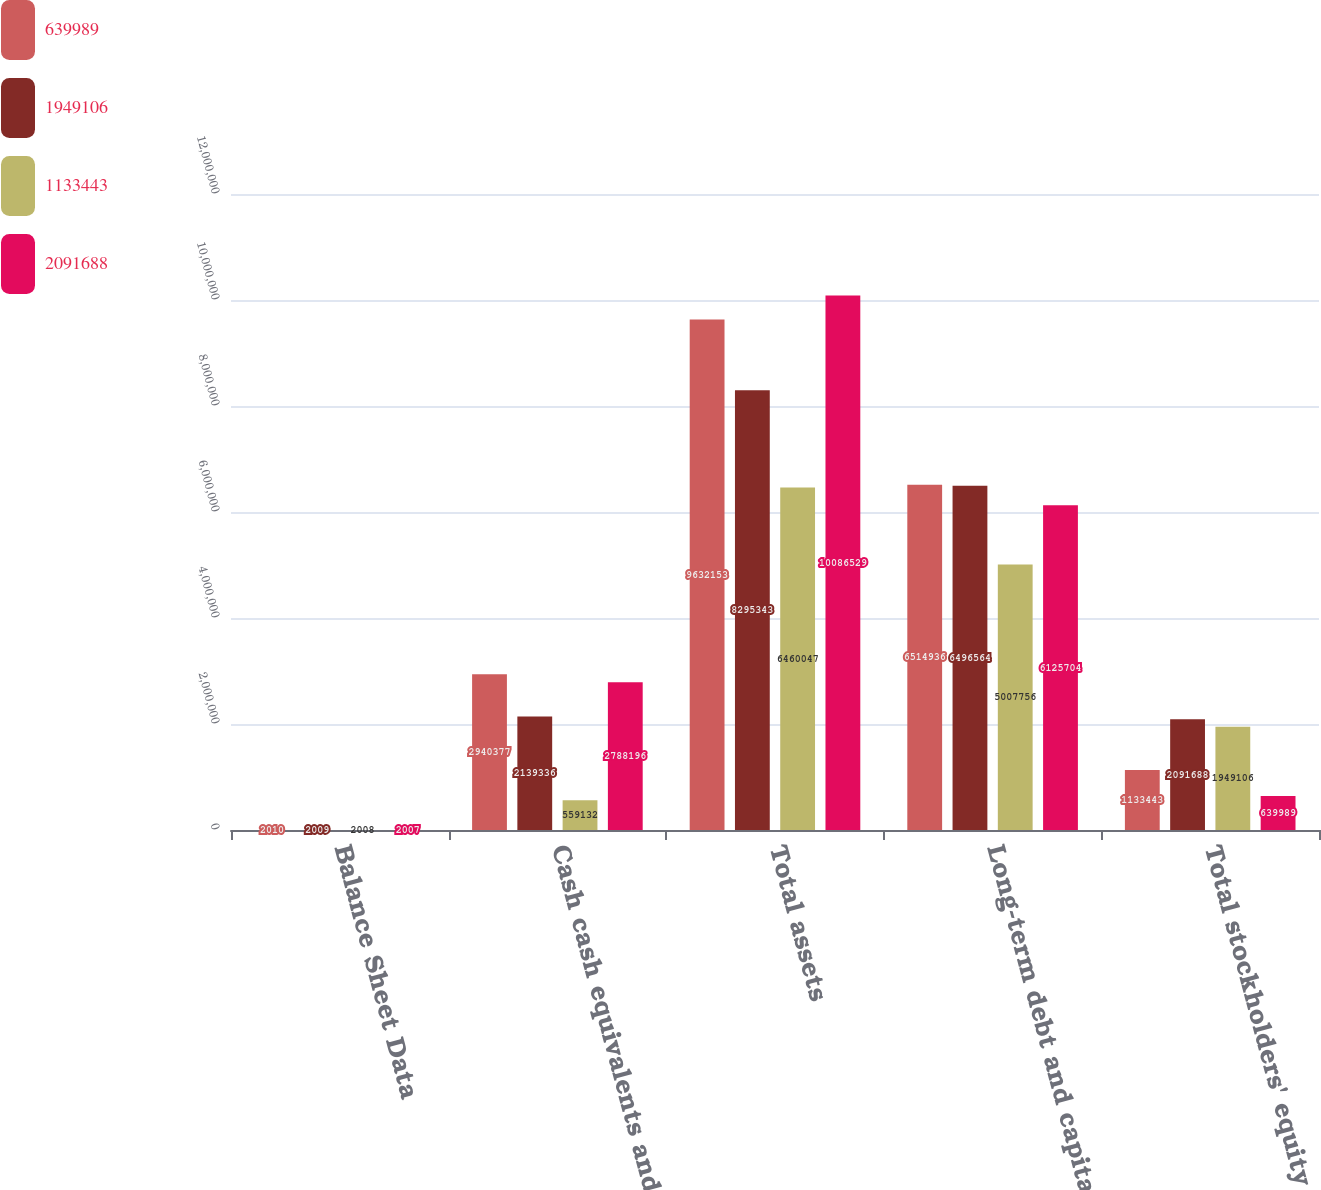Convert chart to OTSL. <chart><loc_0><loc_0><loc_500><loc_500><stacked_bar_chart><ecel><fcel>Balance Sheet Data<fcel>Cash cash equivalents and<fcel>Total assets<fcel>Long-term debt and capital<fcel>Total stockholders' equity<nl><fcel>639989<fcel>2010<fcel>2.94038e+06<fcel>9.63215e+06<fcel>6.51494e+06<fcel>1.13344e+06<nl><fcel>1.94911e+06<fcel>2009<fcel>2.13934e+06<fcel>8.29534e+06<fcel>6.49656e+06<fcel>2.09169e+06<nl><fcel>1.13344e+06<fcel>2008<fcel>559132<fcel>6.46005e+06<fcel>5.00776e+06<fcel>1.94911e+06<nl><fcel>2.09169e+06<fcel>2007<fcel>2.7882e+06<fcel>1.00865e+07<fcel>6.1257e+06<fcel>639989<nl></chart> 